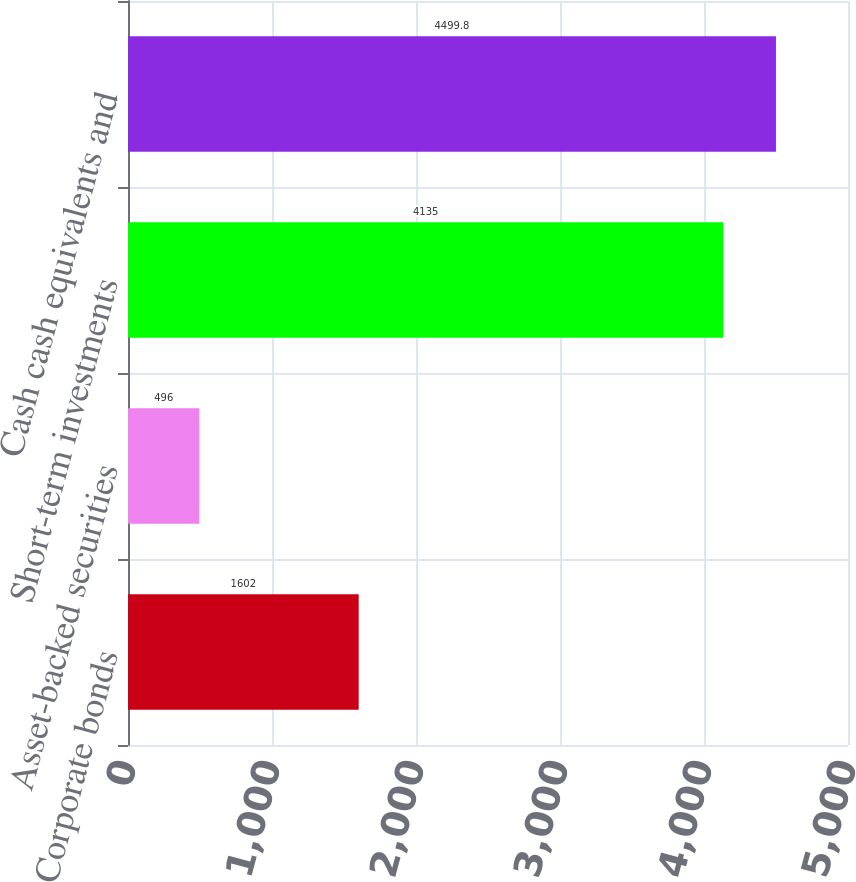Convert chart to OTSL. <chart><loc_0><loc_0><loc_500><loc_500><bar_chart><fcel>Corporate bonds<fcel>Asset-backed securities<fcel>Short-term investments<fcel>Cash cash equivalents and<nl><fcel>1602<fcel>496<fcel>4135<fcel>4499.8<nl></chart> 